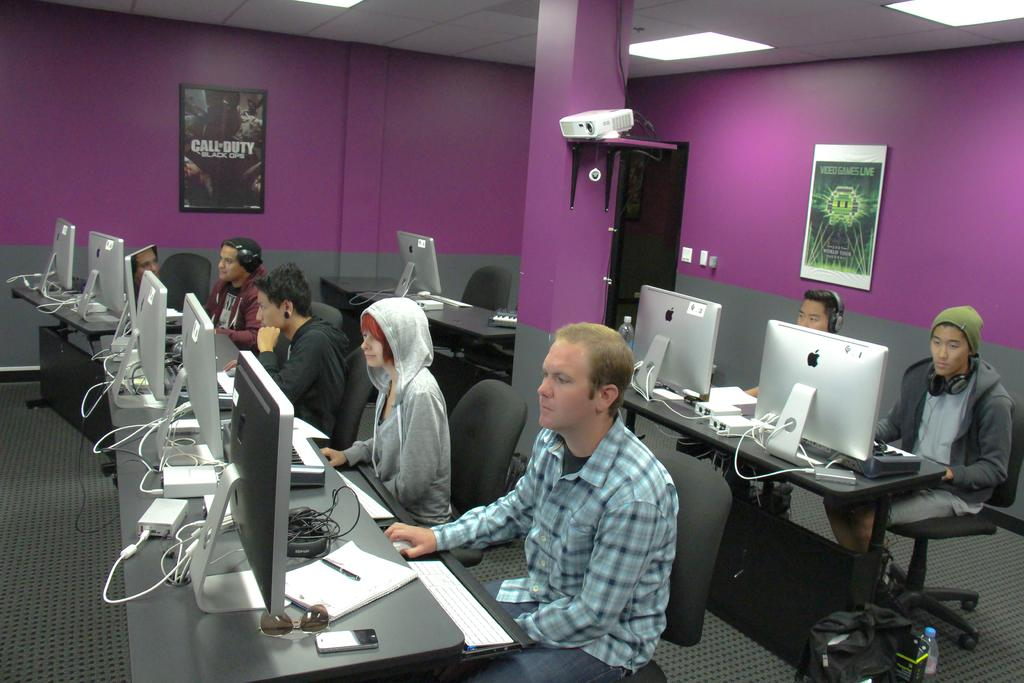Provide a one-sentence caption for the provided image. Several people sitting at PCs with a Call of Duty poster on the wall. 